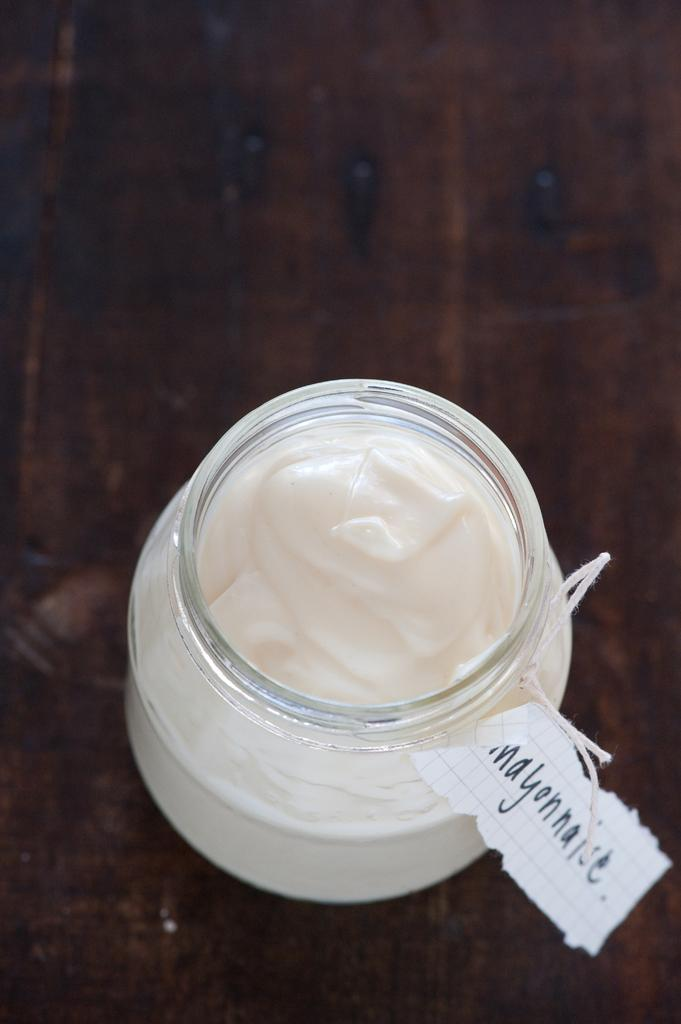<image>
Summarize the visual content of the image. A jar of mayonnaise sitting on top of a brown table. 